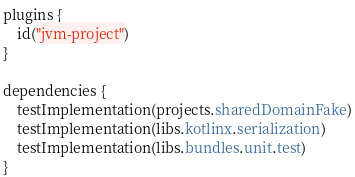Convert code to text. <code><loc_0><loc_0><loc_500><loc_500><_Kotlin_>plugins {
    id("jvm-project")
}

dependencies {
    testImplementation(projects.sharedDomainFake)
    testImplementation(libs.kotlinx.serialization)
    testImplementation(libs.bundles.unit.test)
}
</code> 